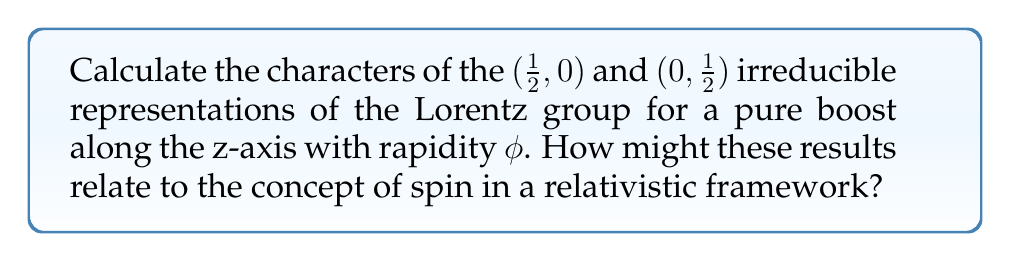Give your solution to this math problem. Let's approach this step-by-step:

1) The Lorentz group has two types of generators: rotations ($J_i$) and boosts ($K_i$). For a pure boost along the z-axis, we only need to consider $K_3$.

2) In the $(1/2, 0)$ and $(0, 1/2)$ representations, the boost generators are given by:

   $(1/2, 0)$: $K_3 = \frac{i}{2}\sigma_3$
   $(0, 1/2)$: $K_3 = -\frac{i}{2}\sigma_3$

   Where $\sigma_3$ is the third Pauli matrix.

3) For a boost with rapidity $\phi$, the group element is $\exp(\phi K_3)$.

4) For the $(1/2, 0)$ representation:
   $$\exp(\phi K_3) = \exp(\frac{i\phi}{2}\sigma_3) = \begin{pmatrix} e^{i\phi/2} & 0 \\ 0 & e^{-i\phi/2} \end{pmatrix}$$

5) For the $(0, 1/2)$ representation:
   $$\exp(\phi K_3) = \exp(-\frac{i\phi}{2}\sigma_3) = \begin{pmatrix} e^{-i\phi/2} & 0 \\ 0 & e^{i\phi/2} \end{pmatrix}$$

6) The character of a representation is the trace of the group element. So:

   For $(1/2, 0)$: $\chi_{(1/2,0)}(\phi) = e^{i\phi/2} + e^{-i\phi/2} = 2\cos(\phi/2)$
   
   For $(0, 1/2)$: $\chi_{(0,1/2)}(\phi) = e^{-i\phi/2} + e^{i\phi/2} = 2\cos(\phi/2)$

7) Relation to spin: These representations describe particles with spin-1/2. The fact that the characters are identical for both representations reflects the symmetry between left-handed and right-handed spinors in a relativistic theory. This is crucial for describing fermions in quantum field theory and relates to the concept of helicity in relativistic physics.

8) From a physics perspective, the hyperbolic nature of these characters ($\cos(\phi/2) = \cosh(i\phi/2)$) reflects the hyperbolic geometry of Minkowski spacetime, which is fundamental to special relativity and our understanding of the universe's structure.
Answer: $\chi_{(1/2,0)}(\phi) = \chi_{(0,1/2)}(\phi) = 2\cos(\phi/2)$ 